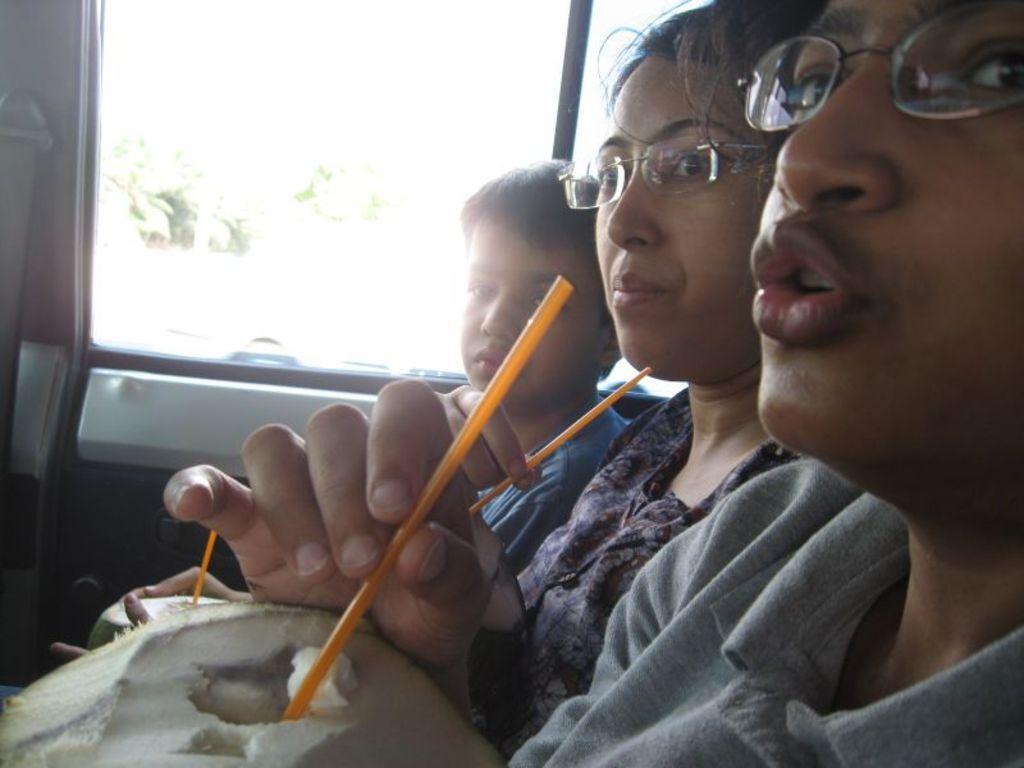Could you give a brief overview of what you see in this image? In this image I can see in the middle a woman is sitting also holding the straw with a coconut, she wore spectacles, dress. Beside her a boy is also sitting, in the middle it looks like a glass window. 